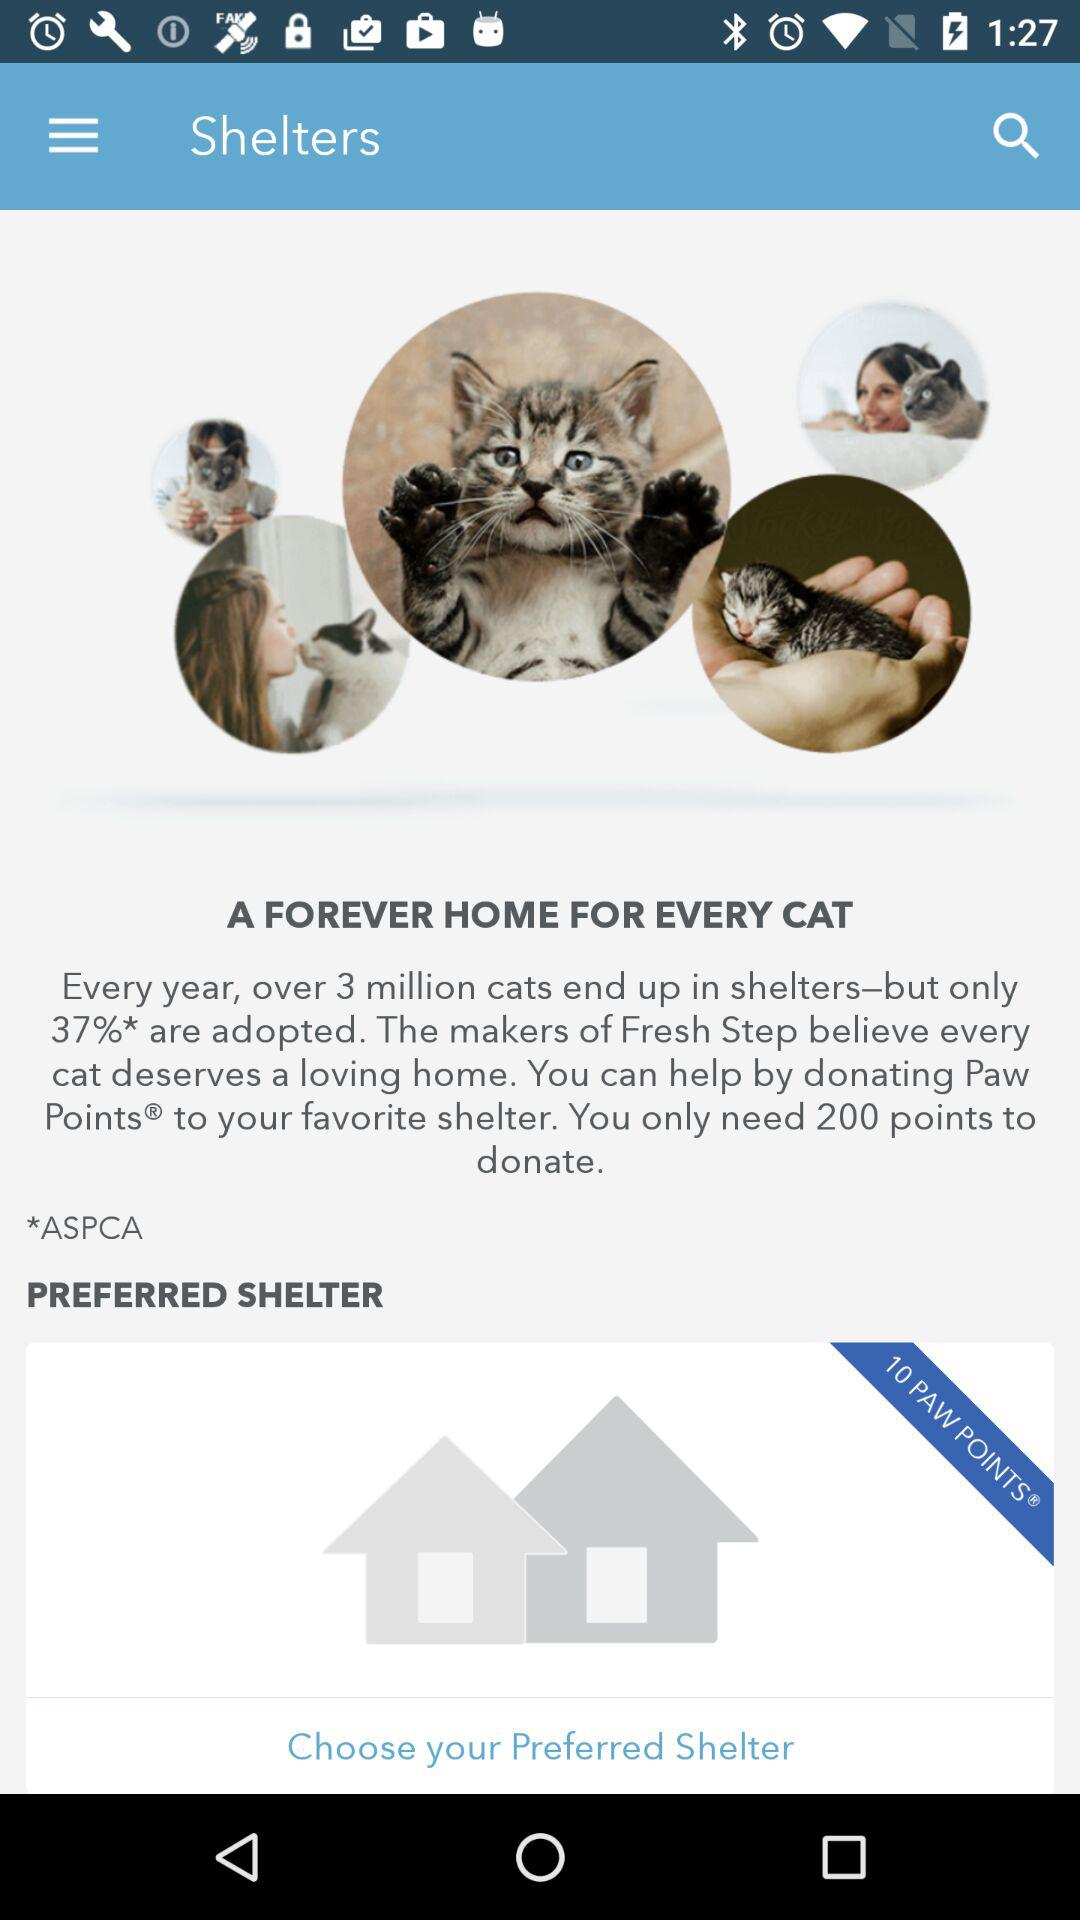How can we help our favorite shelter? You can help by donating Paw Points. 